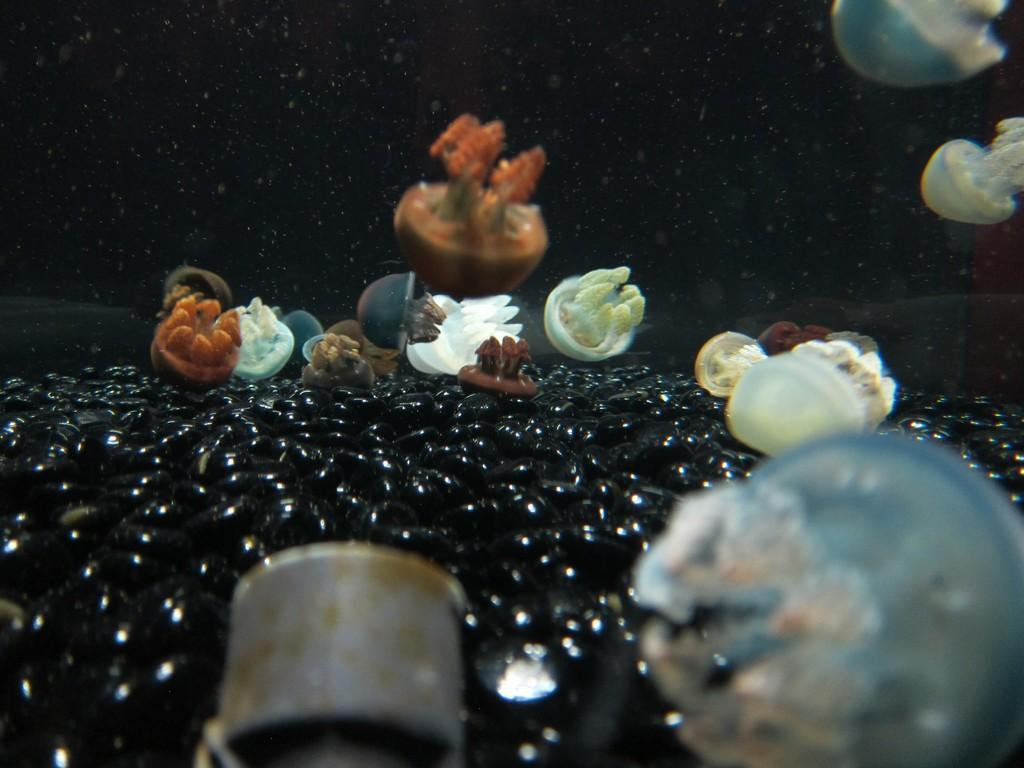What is the setting of the image? The image is underwater. What type of marine life can be seen in the image? There are jellyfishes in the water. Can you describe any other objects or creatures in the water? There are other unspecified things in the water. What type of religion is practiced by the jellyfishes in the image? There is no indication of religion in the image, as it features underwater creatures and objects. 